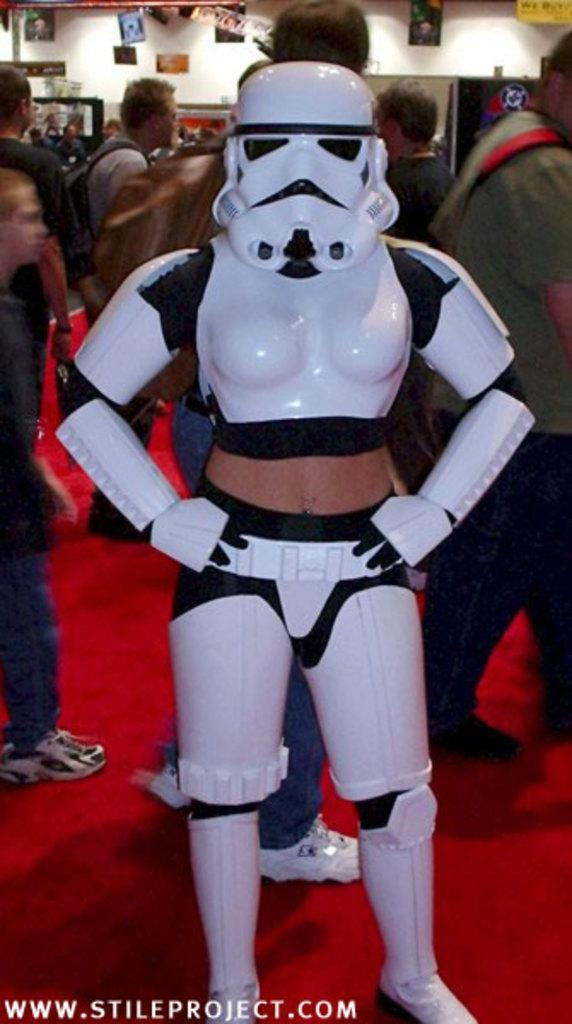What is the main subject in the middle of the image? There is a white color statue in the middle of the image. What can be seen in the background of the image? There are people walking in the background of the image. What is on the floor in the image? There is a red color carpet on the floor in the image. What type of land is the statue standing on in the image? The provided facts do not mention any specific type of land, so it cannot be determined from the image. 